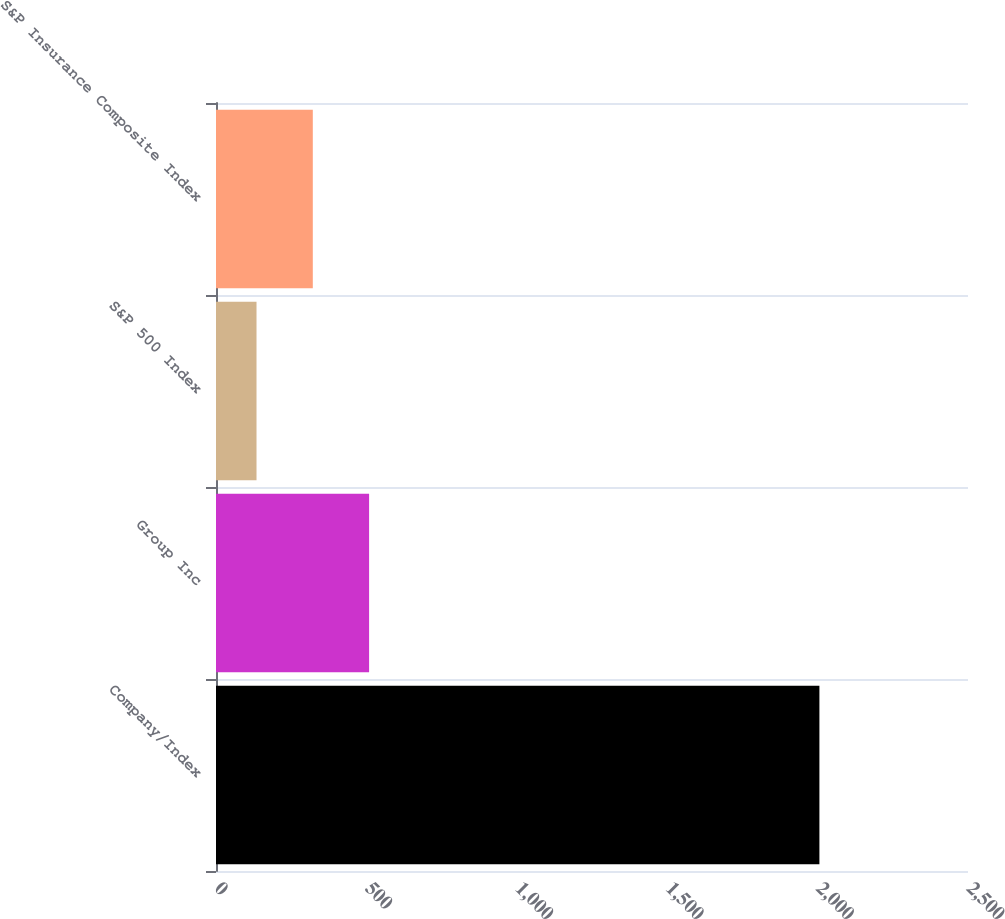Convert chart to OTSL. <chart><loc_0><loc_0><loc_500><loc_500><bar_chart><fcel>Company/Index<fcel>Group Inc<fcel>S&P 500 Index<fcel>S&P Insurance Composite Index<nl><fcel>2006<fcel>508.96<fcel>134.7<fcel>321.83<nl></chart> 